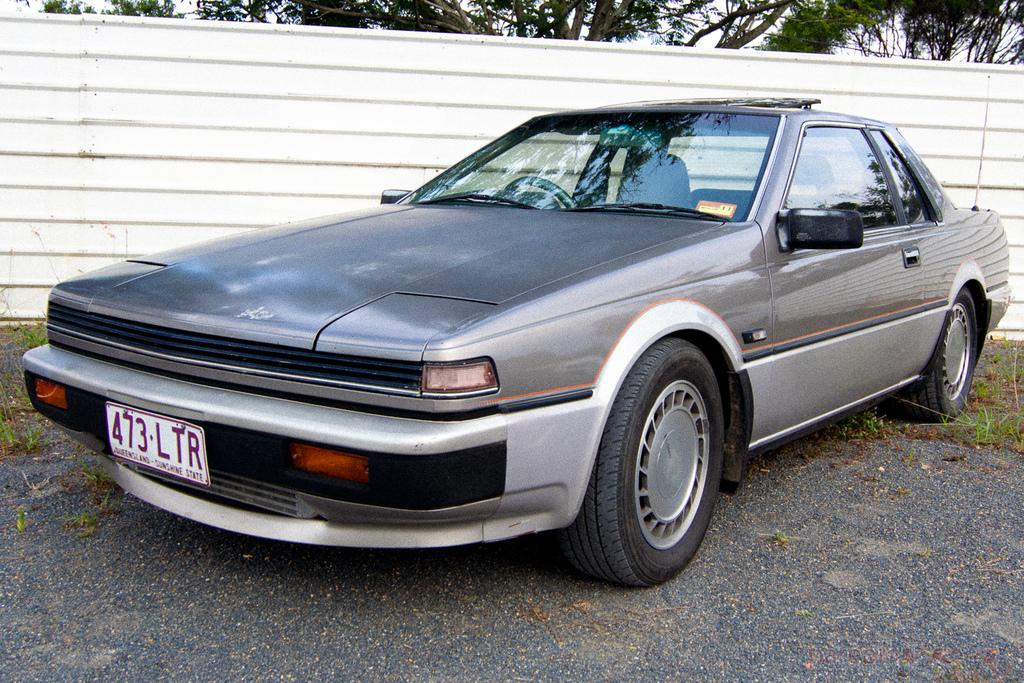What is the main subject of the image? There is a car on the road in the image. What type of vegetation can be seen in the image? There is grass visible in the image. What type of structure is present in the image? There is a compound wall in the image. What can be seen in the background of the image? There are trees and the sky visible in the background of the image. Can you tell me how many yaks are swimming in the background of the image? There are no yaks or swimming activity present in the image. 